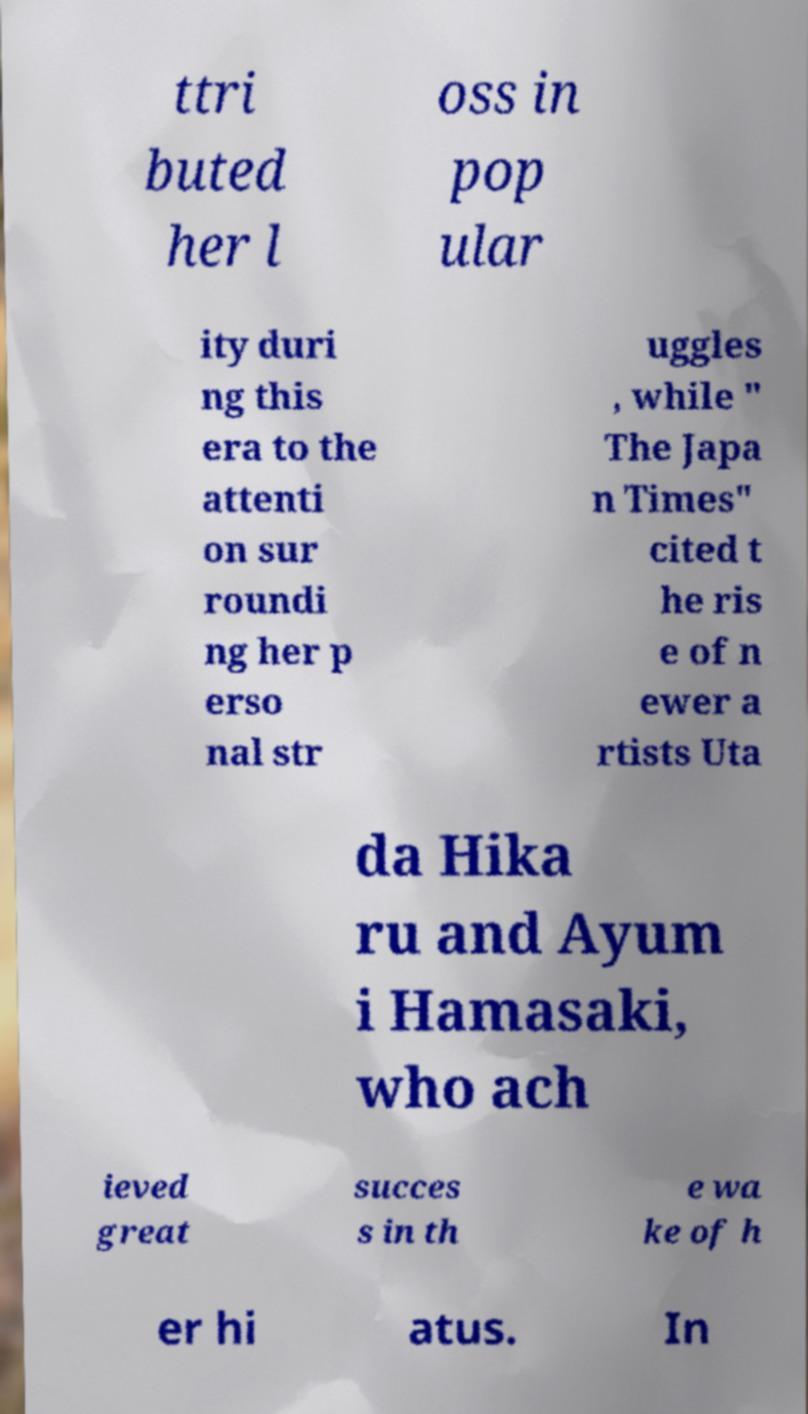What messages or text are displayed in this image? I need them in a readable, typed format. ttri buted her l oss in pop ular ity duri ng this era to the attenti on sur roundi ng her p erso nal str uggles , while " The Japa n Times" cited t he ris e of n ewer a rtists Uta da Hika ru and Ayum i Hamasaki, who ach ieved great succes s in th e wa ke of h er hi atus. In 